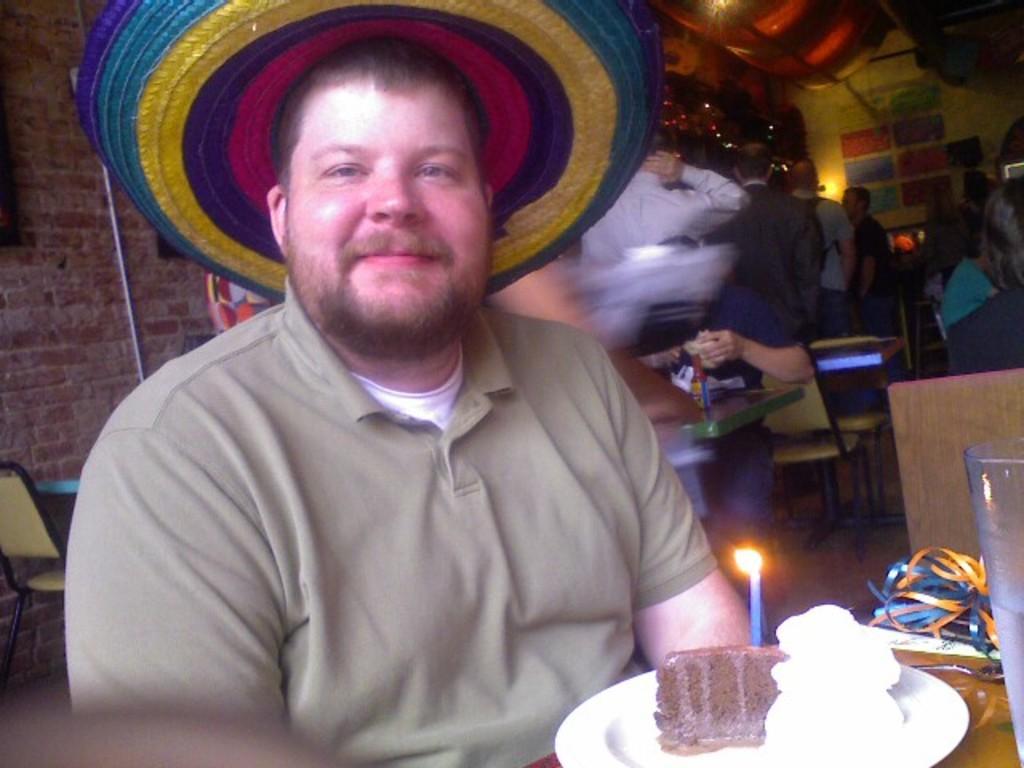How would you summarize this image in a sentence or two? In the picture we can see a man sitting near the table, he is with hat and T-shirt and on the table we can see a plate with slice of cake and candle on it with light and behind the man we can see some people are sitting near the tables and some are standing and in the background we can see a wall with some decorative lights and some posters. 